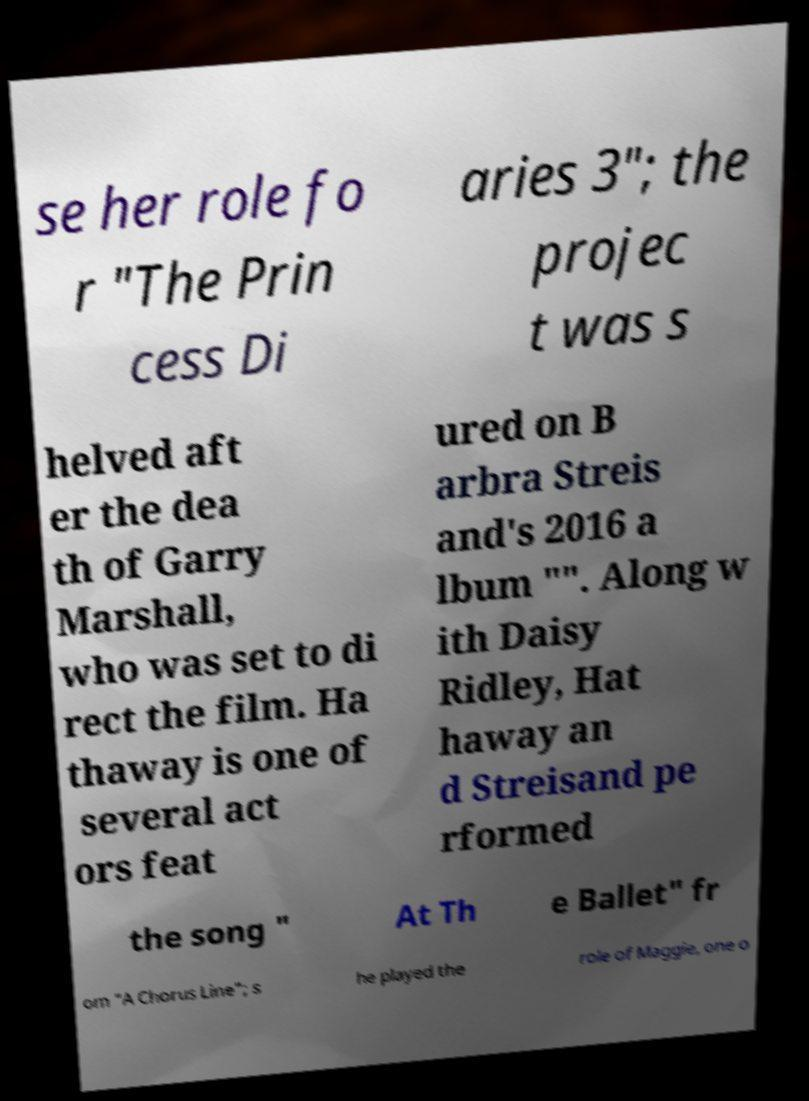What messages or text are displayed in this image? I need them in a readable, typed format. se her role fo r "The Prin cess Di aries 3"; the projec t was s helved aft er the dea th of Garry Marshall, who was set to di rect the film. Ha thaway is one of several act ors feat ured on B arbra Streis and's 2016 a lbum "". Along w ith Daisy Ridley, Hat haway an d Streisand pe rformed the song " At Th e Ballet" fr om "A Chorus Line"; s he played the role of Maggie, one o 